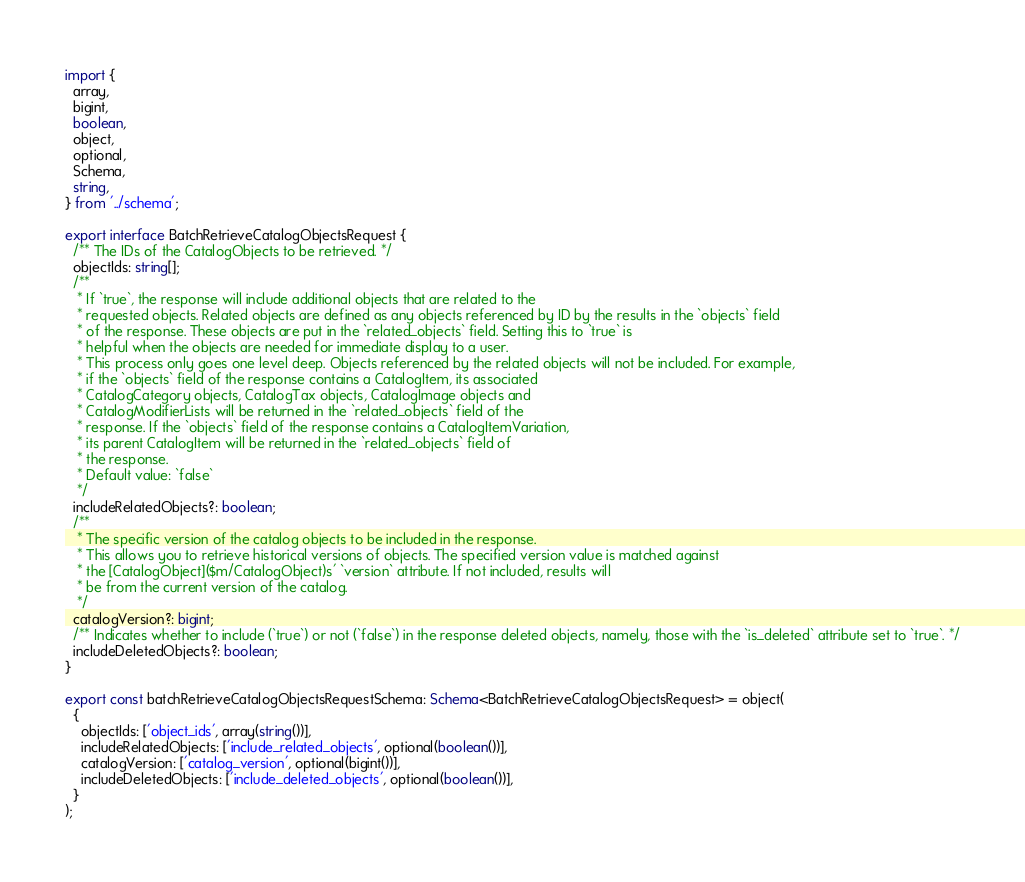<code> <loc_0><loc_0><loc_500><loc_500><_TypeScript_>import {
  array,
  bigint,
  boolean,
  object,
  optional,
  Schema,
  string,
} from '../schema';

export interface BatchRetrieveCatalogObjectsRequest {
  /** The IDs of the CatalogObjects to be retrieved. */
  objectIds: string[];
  /**
   * If `true`, the response will include additional objects that are related to the
   * requested objects. Related objects are defined as any objects referenced by ID by the results in the `objects` field
   * of the response. These objects are put in the `related_objects` field. Setting this to `true` is
   * helpful when the objects are needed for immediate display to a user.
   * This process only goes one level deep. Objects referenced by the related objects will not be included. For example,
   * if the `objects` field of the response contains a CatalogItem, its associated
   * CatalogCategory objects, CatalogTax objects, CatalogImage objects and
   * CatalogModifierLists will be returned in the `related_objects` field of the
   * response. If the `objects` field of the response contains a CatalogItemVariation,
   * its parent CatalogItem will be returned in the `related_objects` field of
   * the response.
   * Default value: `false`
   */
  includeRelatedObjects?: boolean;
  /**
   * The specific version of the catalog objects to be included in the response.
   * This allows you to retrieve historical versions of objects. The specified version value is matched against
   * the [CatalogObject]($m/CatalogObject)s' `version` attribute. If not included, results will
   * be from the current version of the catalog.
   */
  catalogVersion?: bigint;
  /** Indicates whether to include (`true`) or not (`false`) in the response deleted objects, namely, those with the `is_deleted` attribute set to `true`. */
  includeDeletedObjects?: boolean;
}

export const batchRetrieveCatalogObjectsRequestSchema: Schema<BatchRetrieveCatalogObjectsRequest> = object(
  {
    objectIds: ['object_ids', array(string())],
    includeRelatedObjects: ['include_related_objects', optional(boolean())],
    catalogVersion: ['catalog_version', optional(bigint())],
    includeDeletedObjects: ['include_deleted_objects', optional(boolean())],
  }
);
</code> 